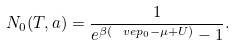Convert formula to latex. <formula><loc_0><loc_0><loc_500><loc_500>N _ { 0 } ( T , a ) = \frac { 1 } { e ^ { \beta ( \ v e p _ { 0 } - \mu + U ) } - 1 } .</formula> 